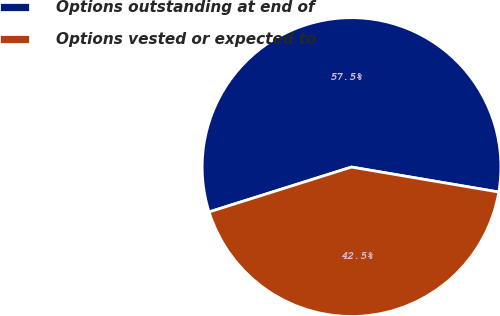<chart> <loc_0><loc_0><loc_500><loc_500><pie_chart><fcel>Options outstanding at end of<fcel>Options vested or expected to<nl><fcel>57.53%<fcel>42.47%<nl></chart> 